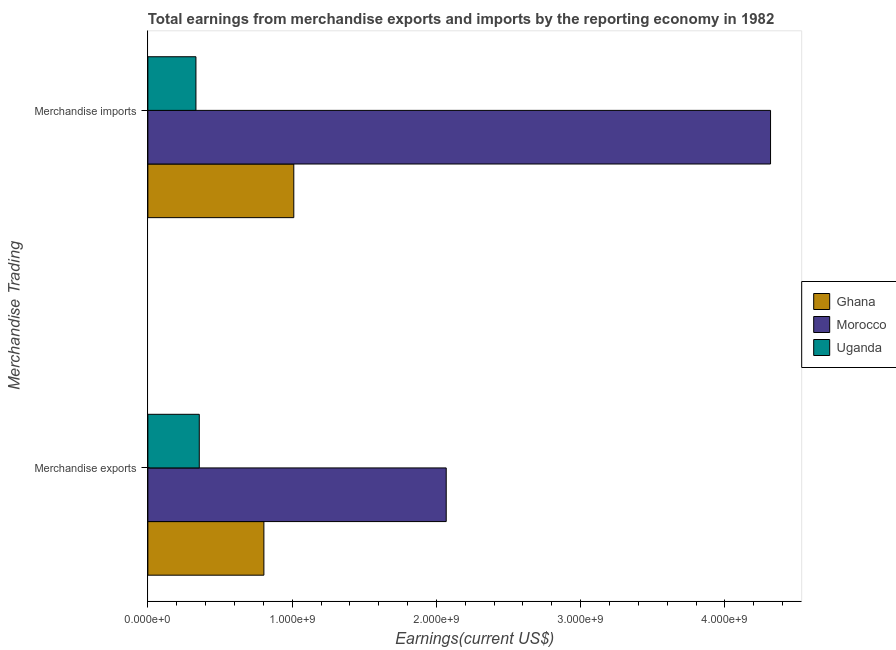How many groups of bars are there?
Your answer should be very brief. 2. How many bars are there on the 2nd tick from the top?
Your answer should be compact. 3. How many bars are there on the 2nd tick from the bottom?
Offer a very short reply. 3. What is the label of the 1st group of bars from the top?
Offer a terse response. Merchandise imports. What is the earnings from merchandise exports in Ghana?
Your answer should be compact. 8.04e+08. Across all countries, what is the maximum earnings from merchandise imports?
Your answer should be very brief. 4.32e+09. Across all countries, what is the minimum earnings from merchandise exports?
Offer a very short reply. 3.56e+08. In which country was the earnings from merchandise imports maximum?
Your answer should be very brief. Morocco. In which country was the earnings from merchandise imports minimum?
Make the answer very short. Uganda. What is the total earnings from merchandise imports in the graph?
Offer a terse response. 5.66e+09. What is the difference between the earnings from merchandise exports in Morocco and that in Uganda?
Ensure brevity in your answer.  1.71e+09. What is the difference between the earnings from merchandise imports in Ghana and the earnings from merchandise exports in Morocco?
Offer a terse response. -1.06e+09. What is the average earnings from merchandise exports per country?
Keep it short and to the point. 1.08e+09. What is the difference between the earnings from merchandise imports and earnings from merchandise exports in Uganda?
Your response must be concise. -2.32e+07. What is the ratio of the earnings from merchandise exports in Morocco to that in Ghana?
Provide a short and direct response. 2.57. What does the 3rd bar from the top in Merchandise imports represents?
Provide a short and direct response. Ghana. What does the 3rd bar from the bottom in Merchandise exports represents?
Offer a very short reply. Uganda. Are all the bars in the graph horizontal?
Ensure brevity in your answer.  Yes. How many countries are there in the graph?
Offer a very short reply. 3. Does the graph contain grids?
Make the answer very short. No. How many legend labels are there?
Provide a succinct answer. 3. How are the legend labels stacked?
Your answer should be very brief. Vertical. What is the title of the graph?
Keep it short and to the point. Total earnings from merchandise exports and imports by the reporting economy in 1982. What is the label or title of the X-axis?
Give a very brief answer. Earnings(current US$). What is the label or title of the Y-axis?
Make the answer very short. Merchandise Trading. What is the Earnings(current US$) in Ghana in Merchandise exports?
Ensure brevity in your answer.  8.04e+08. What is the Earnings(current US$) in Morocco in Merchandise exports?
Give a very brief answer. 2.07e+09. What is the Earnings(current US$) in Uganda in Merchandise exports?
Offer a terse response. 3.56e+08. What is the Earnings(current US$) in Ghana in Merchandise imports?
Make the answer very short. 1.01e+09. What is the Earnings(current US$) in Morocco in Merchandise imports?
Keep it short and to the point. 4.32e+09. What is the Earnings(current US$) in Uganda in Merchandise imports?
Make the answer very short. 3.33e+08. Across all Merchandise Trading, what is the maximum Earnings(current US$) in Ghana?
Ensure brevity in your answer.  1.01e+09. Across all Merchandise Trading, what is the maximum Earnings(current US$) of Morocco?
Keep it short and to the point. 4.32e+09. Across all Merchandise Trading, what is the maximum Earnings(current US$) in Uganda?
Your response must be concise. 3.56e+08. Across all Merchandise Trading, what is the minimum Earnings(current US$) of Ghana?
Keep it short and to the point. 8.04e+08. Across all Merchandise Trading, what is the minimum Earnings(current US$) of Morocco?
Your response must be concise. 2.07e+09. Across all Merchandise Trading, what is the minimum Earnings(current US$) of Uganda?
Provide a short and direct response. 3.33e+08. What is the total Earnings(current US$) of Ghana in the graph?
Your response must be concise. 1.82e+09. What is the total Earnings(current US$) in Morocco in the graph?
Offer a terse response. 6.38e+09. What is the total Earnings(current US$) of Uganda in the graph?
Give a very brief answer. 6.90e+08. What is the difference between the Earnings(current US$) of Ghana in Merchandise exports and that in Merchandise imports?
Your response must be concise. -2.07e+08. What is the difference between the Earnings(current US$) of Morocco in Merchandise exports and that in Merchandise imports?
Offer a terse response. -2.25e+09. What is the difference between the Earnings(current US$) in Uganda in Merchandise exports and that in Merchandise imports?
Provide a short and direct response. 2.32e+07. What is the difference between the Earnings(current US$) in Ghana in Merchandise exports and the Earnings(current US$) in Morocco in Merchandise imports?
Offer a terse response. -3.51e+09. What is the difference between the Earnings(current US$) of Ghana in Merchandise exports and the Earnings(current US$) of Uganda in Merchandise imports?
Ensure brevity in your answer.  4.71e+08. What is the difference between the Earnings(current US$) of Morocco in Merchandise exports and the Earnings(current US$) of Uganda in Merchandise imports?
Ensure brevity in your answer.  1.73e+09. What is the average Earnings(current US$) in Ghana per Merchandise Trading?
Keep it short and to the point. 9.08e+08. What is the average Earnings(current US$) of Morocco per Merchandise Trading?
Offer a very short reply. 3.19e+09. What is the average Earnings(current US$) of Uganda per Merchandise Trading?
Offer a very short reply. 3.45e+08. What is the difference between the Earnings(current US$) of Ghana and Earnings(current US$) of Morocco in Merchandise exports?
Provide a short and direct response. -1.26e+09. What is the difference between the Earnings(current US$) in Ghana and Earnings(current US$) in Uganda in Merchandise exports?
Offer a terse response. 4.48e+08. What is the difference between the Earnings(current US$) in Morocco and Earnings(current US$) in Uganda in Merchandise exports?
Offer a very short reply. 1.71e+09. What is the difference between the Earnings(current US$) in Ghana and Earnings(current US$) in Morocco in Merchandise imports?
Ensure brevity in your answer.  -3.30e+09. What is the difference between the Earnings(current US$) in Ghana and Earnings(current US$) in Uganda in Merchandise imports?
Provide a short and direct response. 6.78e+08. What is the difference between the Earnings(current US$) of Morocco and Earnings(current US$) of Uganda in Merchandise imports?
Make the answer very short. 3.98e+09. What is the ratio of the Earnings(current US$) in Ghana in Merchandise exports to that in Merchandise imports?
Keep it short and to the point. 0.8. What is the ratio of the Earnings(current US$) of Morocco in Merchandise exports to that in Merchandise imports?
Offer a very short reply. 0.48. What is the ratio of the Earnings(current US$) in Uganda in Merchandise exports to that in Merchandise imports?
Provide a succinct answer. 1.07. What is the difference between the highest and the second highest Earnings(current US$) in Ghana?
Provide a succinct answer. 2.07e+08. What is the difference between the highest and the second highest Earnings(current US$) of Morocco?
Offer a very short reply. 2.25e+09. What is the difference between the highest and the second highest Earnings(current US$) in Uganda?
Give a very brief answer. 2.32e+07. What is the difference between the highest and the lowest Earnings(current US$) of Ghana?
Your response must be concise. 2.07e+08. What is the difference between the highest and the lowest Earnings(current US$) in Morocco?
Your response must be concise. 2.25e+09. What is the difference between the highest and the lowest Earnings(current US$) of Uganda?
Provide a short and direct response. 2.32e+07. 